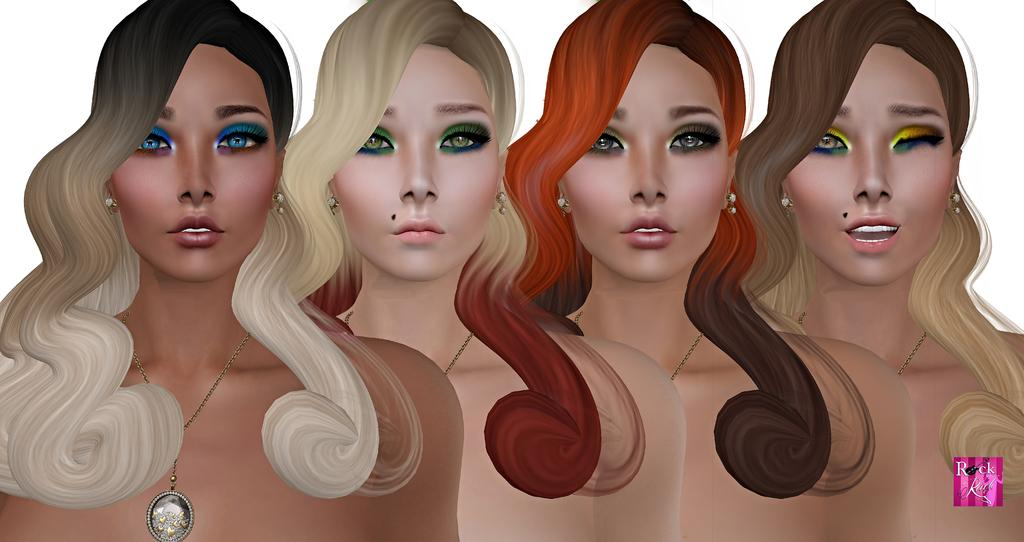What is the main subject of the image? The main subject of the image is a lady. Has the image been altered in any way? Yes, the image is an edited image of a lady. Is there any text or symbol present at the bottom of the image? Yes, there is a logo at the bottom of the image. How does the moon affect the lady's appearance in the image? The moon is not present in the image, so it cannot affect the lady's appearance. What unit of measurement is used to determine the lady's height in the image? There is no information provided about the lady's height or any unit of measurement in the image. 